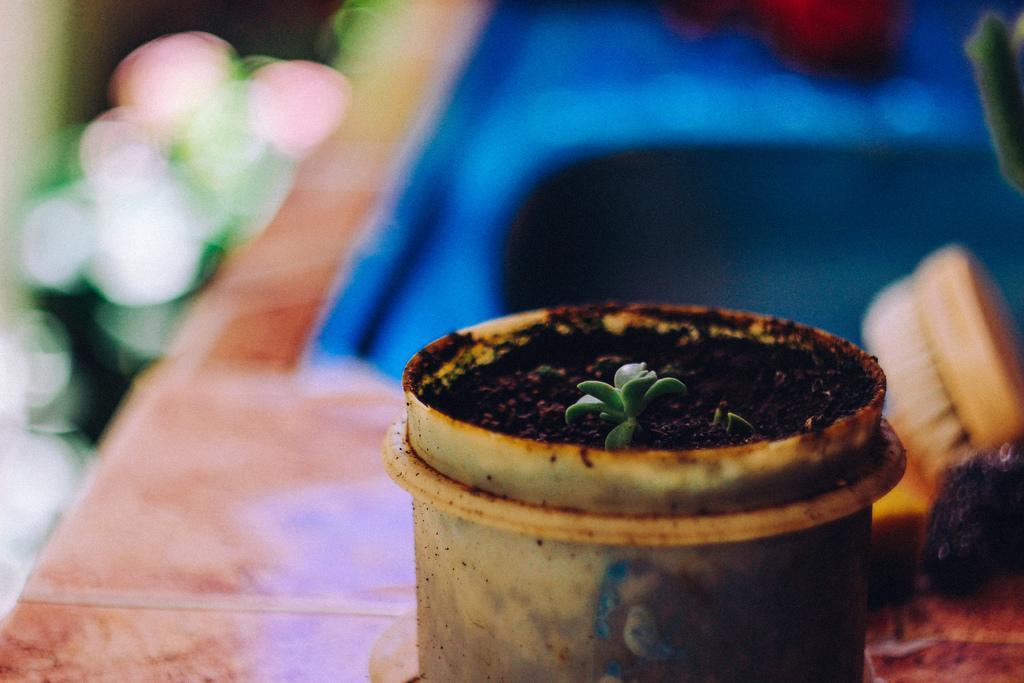What is the main object in the center of the image? There is a table in the center of the image. What is placed on the table? There is a plant pot and a plant on the table. Are there any other objects on the table? Yes, there are other objects on the table. What is the weight of the beast that is kicking the table in the image? There is no beast or kicking action present in the image; it features a table with a plant pot and a plant on it. 